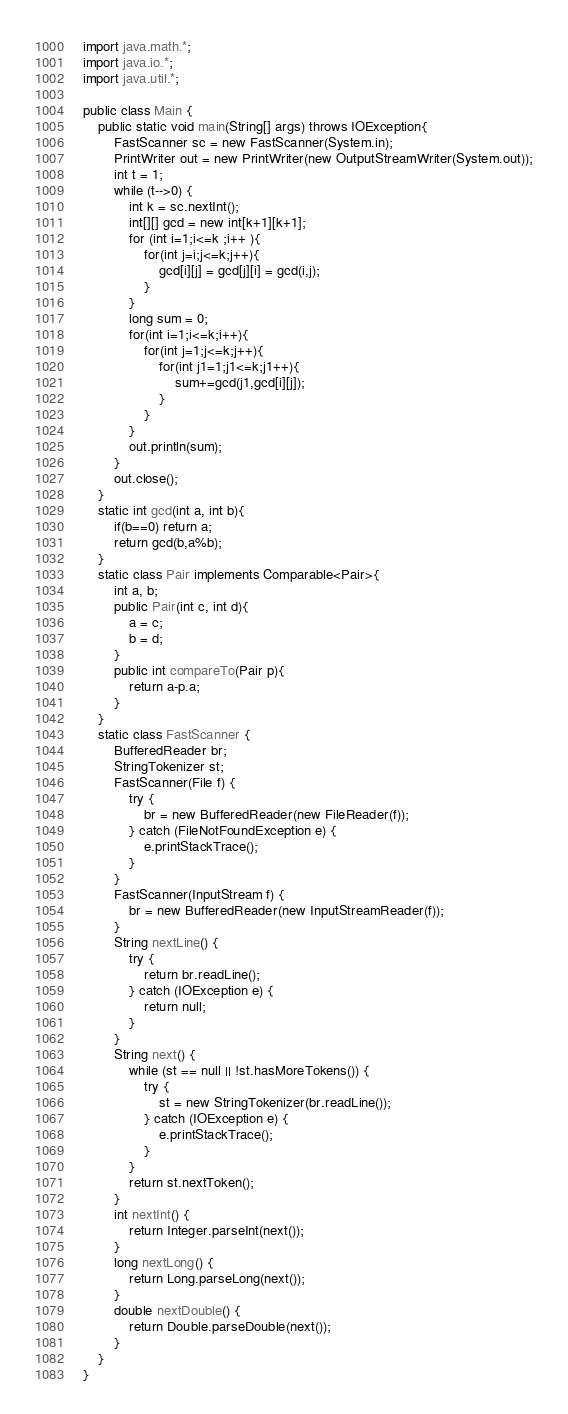Convert code to text. <code><loc_0><loc_0><loc_500><loc_500><_Java_>import java.math.*;
import java.io.*;
import java.util.*;

public class Main {
	public static void main(String[] args) throws IOException{
		FastScanner sc = new FastScanner(System.in);
		PrintWriter out = new PrintWriter(new OutputStreamWriter(System.out));
		int t = 1;
		while (t-->0) {
		    int k = sc.nextInt();
		    int[][] gcd = new int[k+1][k+1];
		    for (int i=1;i<=k ;i++ ){
		        for(int j=i;j<=k;j++){
		            gcd[i][j] = gcd[j][i] = gcd(i,j);
		        }
		    }
		    long sum = 0;
		    for(int i=1;i<=k;i++){
		        for(int j=1;j<=k;j++){
		            for(int j1=1;j1<=k;j1++){
		                sum+=gcd(j1,gcd[i][j]);
		            }
		        }
		    }
		    out.println(sum);
		}
		out.close();
	}
	static int gcd(int a, int b){
	    if(b==0) return a;
	    return gcd(b,a%b);
	}
	static class Pair implements Comparable<Pair>{
		int a, b;
		public Pair(int c, int d){
			a = c;
			b = d;
		}
		public int compareTo(Pair p){
		    return a-p.a;
		}
	}
	static class FastScanner {
		BufferedReader br;
		StringTokenizer st;
		FastScanner(File f) {
			try {
				br = new BufferedReader(new FileReader(f));
			} catch (FileNotFoundException e) {
				e.printStackTrace();
			}
		}
		FastScanner(InputStream f) {
			br = new BufferedReader(new InputStreamReader(f));
		}
		String nextLine() {
			try {
				return br.readLine();
			} catch (IOException e) {
				return null;
			}
		}
		String next() {
			while (st == null || !st.hasMoreTokens()) {
				try {
					st = new StringTokenizer(br.readLine());
				} catch (IOException e) {
					e.printStackTrace();
				}
			}
			return st.nextToken();
		}
		int nextInt() {
			return Integer.parseInt(next());
		}
		long nextLong() {
			return Long.parseLong(next());
		}
		double nextDouble() {
			return Double.parseDouble(next());
		}
	}
}</code> 